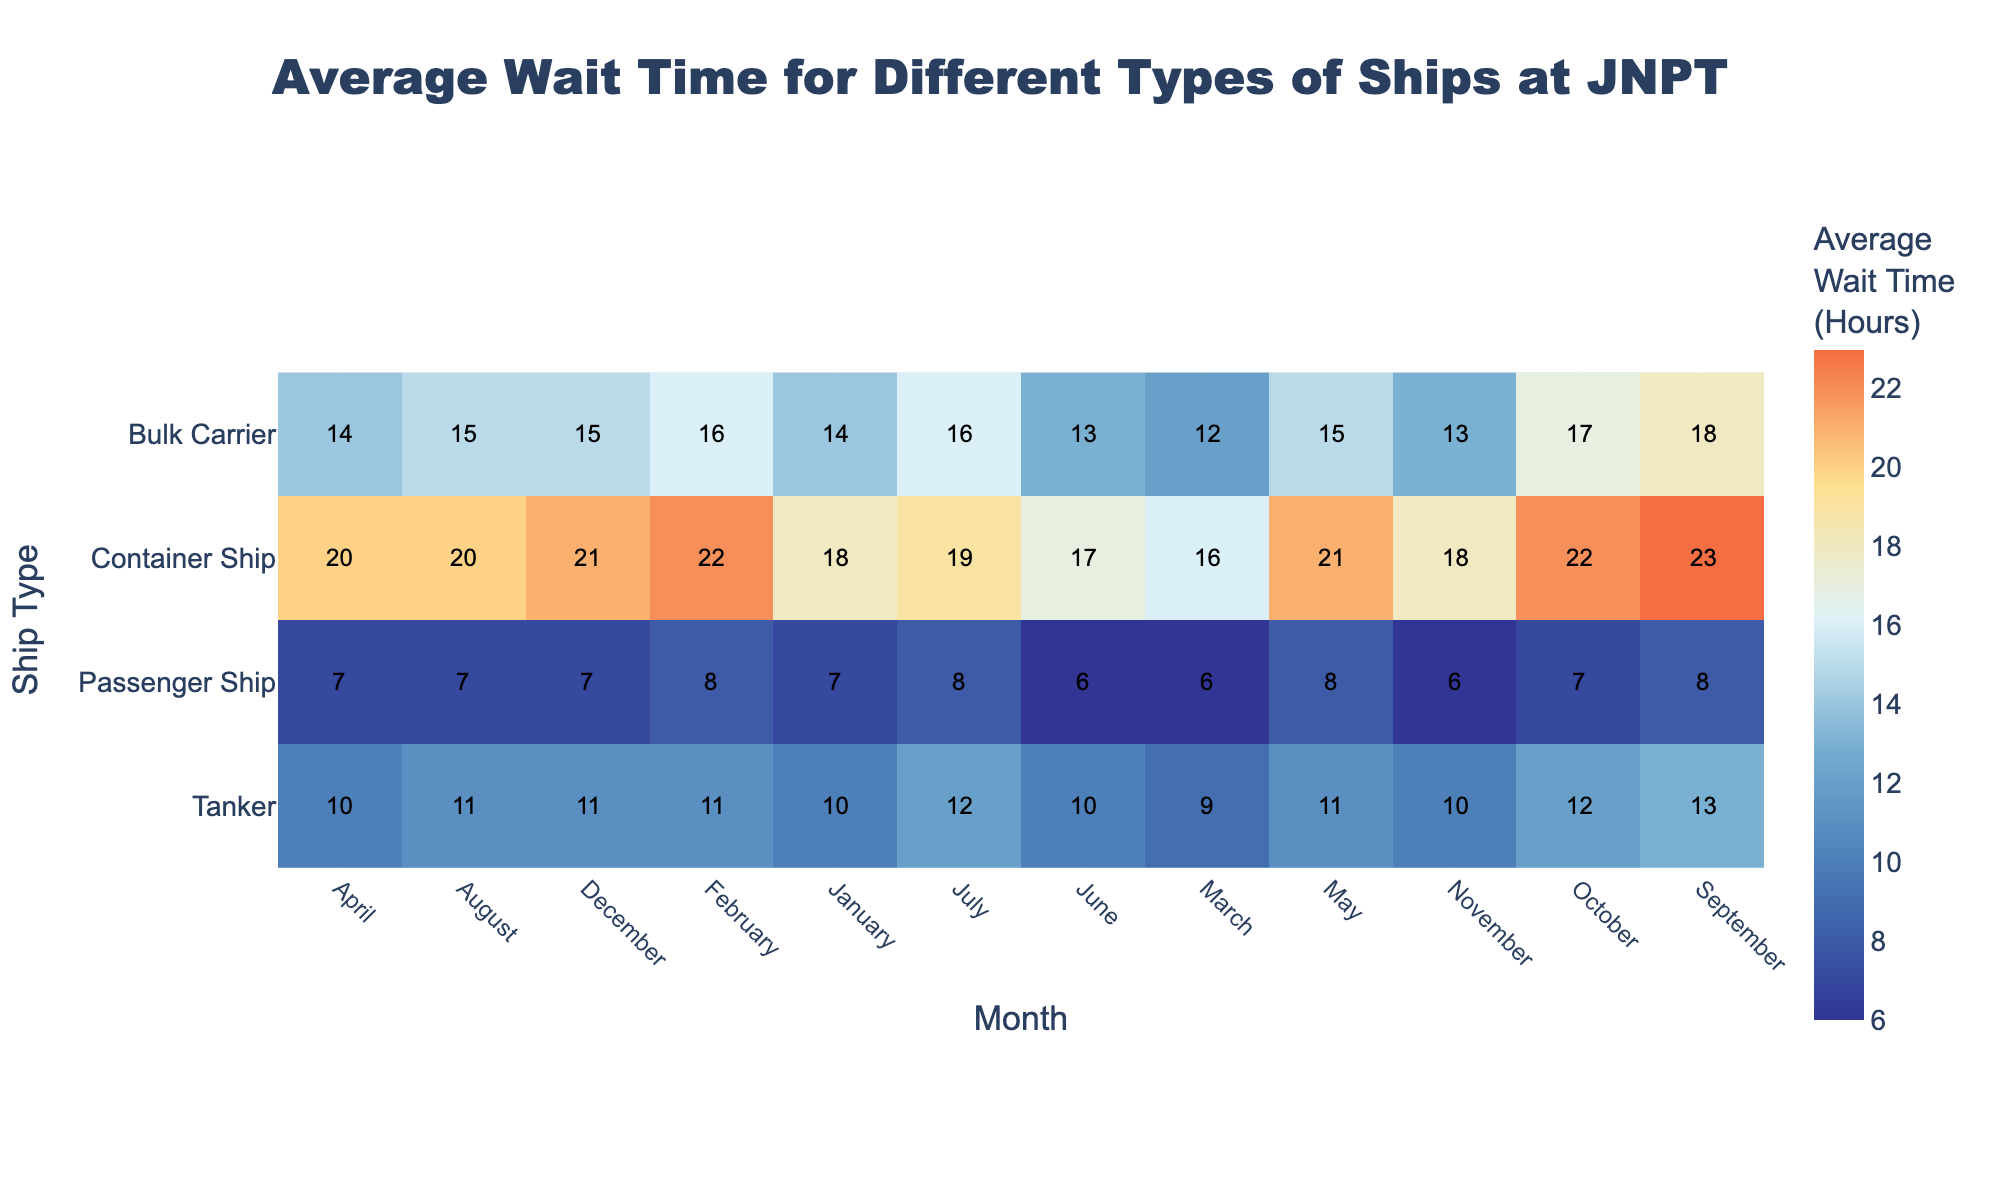What is the average wait time for Container Ships in March? Look at the Cell in the row labeled "Container Ship" and the column labeled "March" in the heatmap. The value in this cell is the average wait time.
Answer: 16 Which type of ship had the least average wait time in November? Review each cell in the November column and find the lowest value. This occurs at the intersection of the November column and the "Passenger Ship" row.
Answer: Passenger Ship In which month did Bulk Carriers have the longest average wait time? Scan the row for "Bulk Carrier" and identify the cell with the highest value. The month corresponding to this cell in the column header is the answer.
Answer: September What's the range of the average wait times for Tankers over the year? Identify the minimum and maximum values in the row for "Tanker". Subtract the minimum value from the maximum value to find the range.
Answer: 4 How does the average wait time for Passenger Ships in July compare to Bulk Carriers in the same month? Compare the values in the row labeled "Passenger Ship" and "Bulk Carrier" under the month of July.
Answer: Passenger Ships have 8 hours, whereas Bulk Carriers have 16 hours What is the most common average wait time across all types of ships and months? Observe the entire heatmap to identify the most frequently occurring value.
Answer: 16 Which ship type had the highest average wait time overall, and what was it? Locate the highest value in the entire heatmap and identify the corresponding ship type and that value.
Answer: Container Ship, 23 Which two months have the highest average wait times and for which ship types? Identify the two highest values in the heatmap and note their respective months and ship types.
Answer: September (Container Ship), September (Bulk Carrier) What's the difference between the average wait times for Bulk Carriers and Tankers in February? Subtract the value for "Tanker" in February from the value for "Bulk Carrier" in February.
Answer: 5 Which month showed the least variation in average wait times across all ship types? Check each column and assess the differences between the maximum and minimum values within that column. The month with the smallest range has the least variation.
Answer: January 